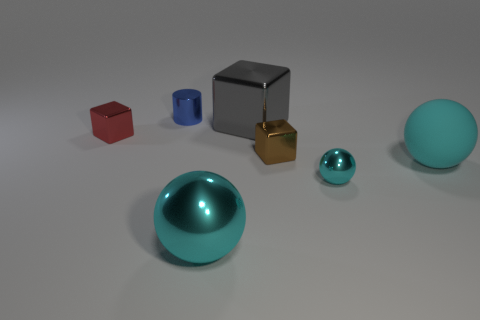What is the color of the large metallic sphere?
Give a very brief answer. Cyan. Is there a large object that is right of the tiny red metallic block that is to the left of the large cyan metallic ball?
Provide a short and direct response. Yes. What material is the small cyan sphere?
Give a very brief answer. Metal. Is the material of the big ball that is in front of the small cyan object the same as the small block to the left of the large cyan metal object?
Give a very brief answer. Yes. Are there any other things that are the same color as the matte thing?
Offer a terse response. Yes. What is the color of the tiny metallic object that is the same shape as the big cyan rubber thing?
Offer a very short reply. Cyan. There is a block that is in front of the big gray shiny object and on the right side of the metallic cylinder; what is its size?
Offer a terse response. Small. Do the cyan metal object that is to the right of the big gray block and the cyan object in front of the tiny cyan metallic thing have the same shape?
Ensure brevity in your answer.  Yes. What is the shape of the tiny metallic object that is the same color as the rubber thing?
Ensure brevity in your answer.  Sphere. What number of large cyan objects have the same material as the tiny red cube?
Provide a short and direct response. 1. 